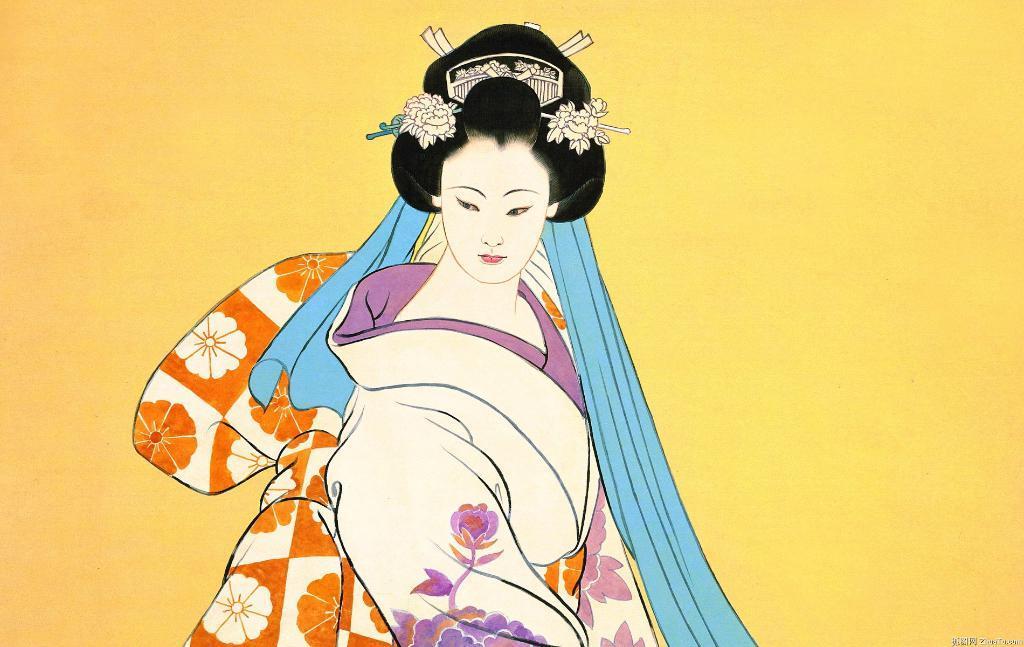How would you summarize this image in a sentence or two? In this image I can see drawing of a woman. I can see she is wearing white dress and also I can see blue colour thing over here. In the background I can see yellow colour. 